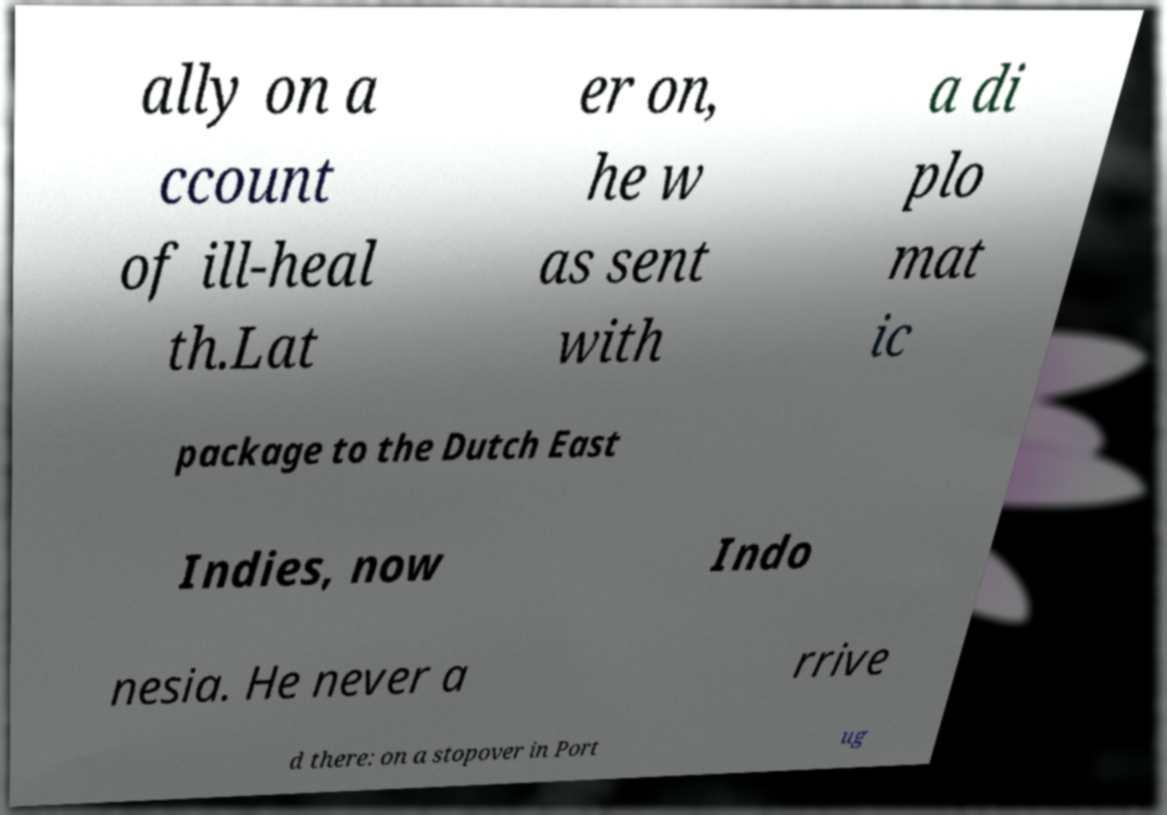Could you assist in decoding the text presented in this image and type it out clearly? ally on a ccount of ill-heal th.Lat er on, he w as sent with a di plo mat ic package to the Dutch East Indies, now Indo nesia. He never a rrive d there: on a stopover in Port ug 